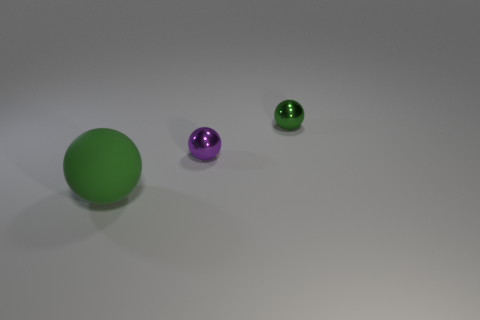What is the color of the metallic object that is in front of the sphere that is right of the small purple thing?
Ensure brevity in your answer.  Purple. Are there fewer small green metal balls that are left of the large matte thing than big green matte objects that are behind the small green metallic thing?
Keep it short and to the point. No. There is a tiny ball that is the same color as the large matte thing; what material is it?
Your answer should be very brief. Metal. How many things are tiny balls that are in front of the tiny green sphere or large brown rubber cubes?
Give a very brief answer. 1. Do the matte ball that is on the left side of the green metallic object and the small green metal sphere have the same size?
Provide a short and direct response. No. Are there fewer spheres to the right of the tiny green metal sphere than green objects?
Provide a short and direct response. Yes. There is a sphere that is the same size as the purple metallic thing; what is its material?
Your answer should be compact. Metal. How many tiny objects are either purple spheres or green matte things?
Your answer should be very brief. 1. How many things are green things that are on the right side of the large green ball or green things behind the big green matte sphere?
Ensure brevity in your answer.  1. Is the number of green rubber balls less than the number of small spheres?
Make the answer very short. Yes. 